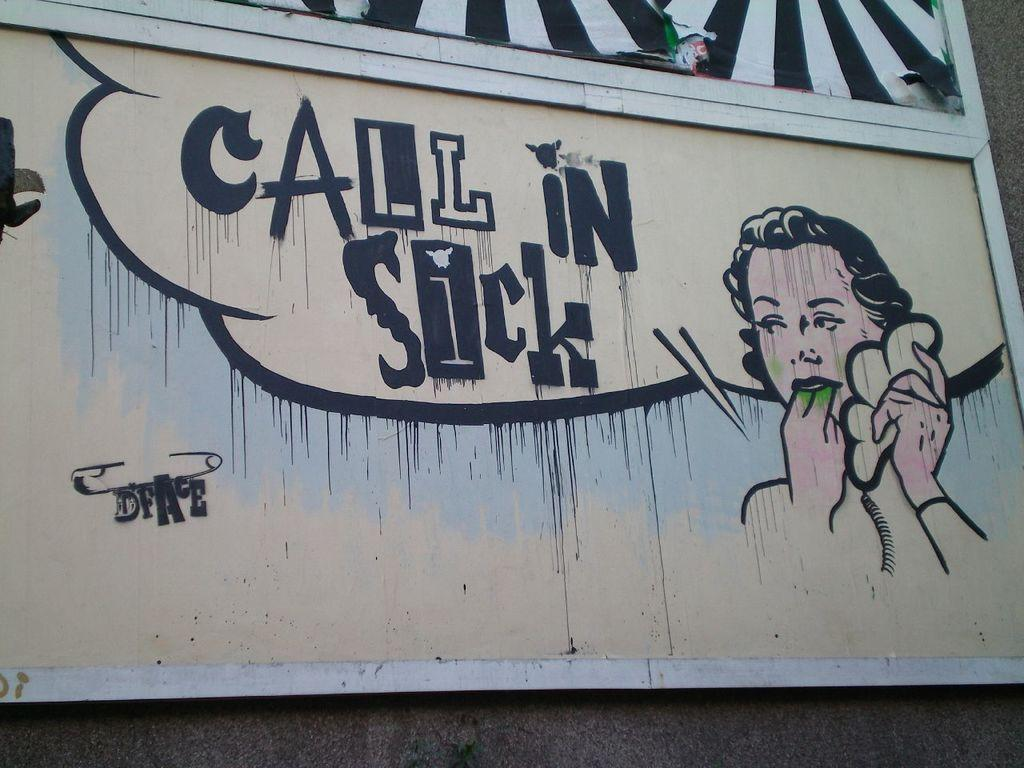What type of visual representation is the image? The image is a poster. What can be seen on the poster? There is a depiction on the poster. What else is featured on the poster besides the image? There is text on the poster. How many feathers can be seen on the poster? There are no feathers present on the poster; it features a depiction and text. Is the poster made of oil? The poster is not made of oil; it is a printed or digital representation. 